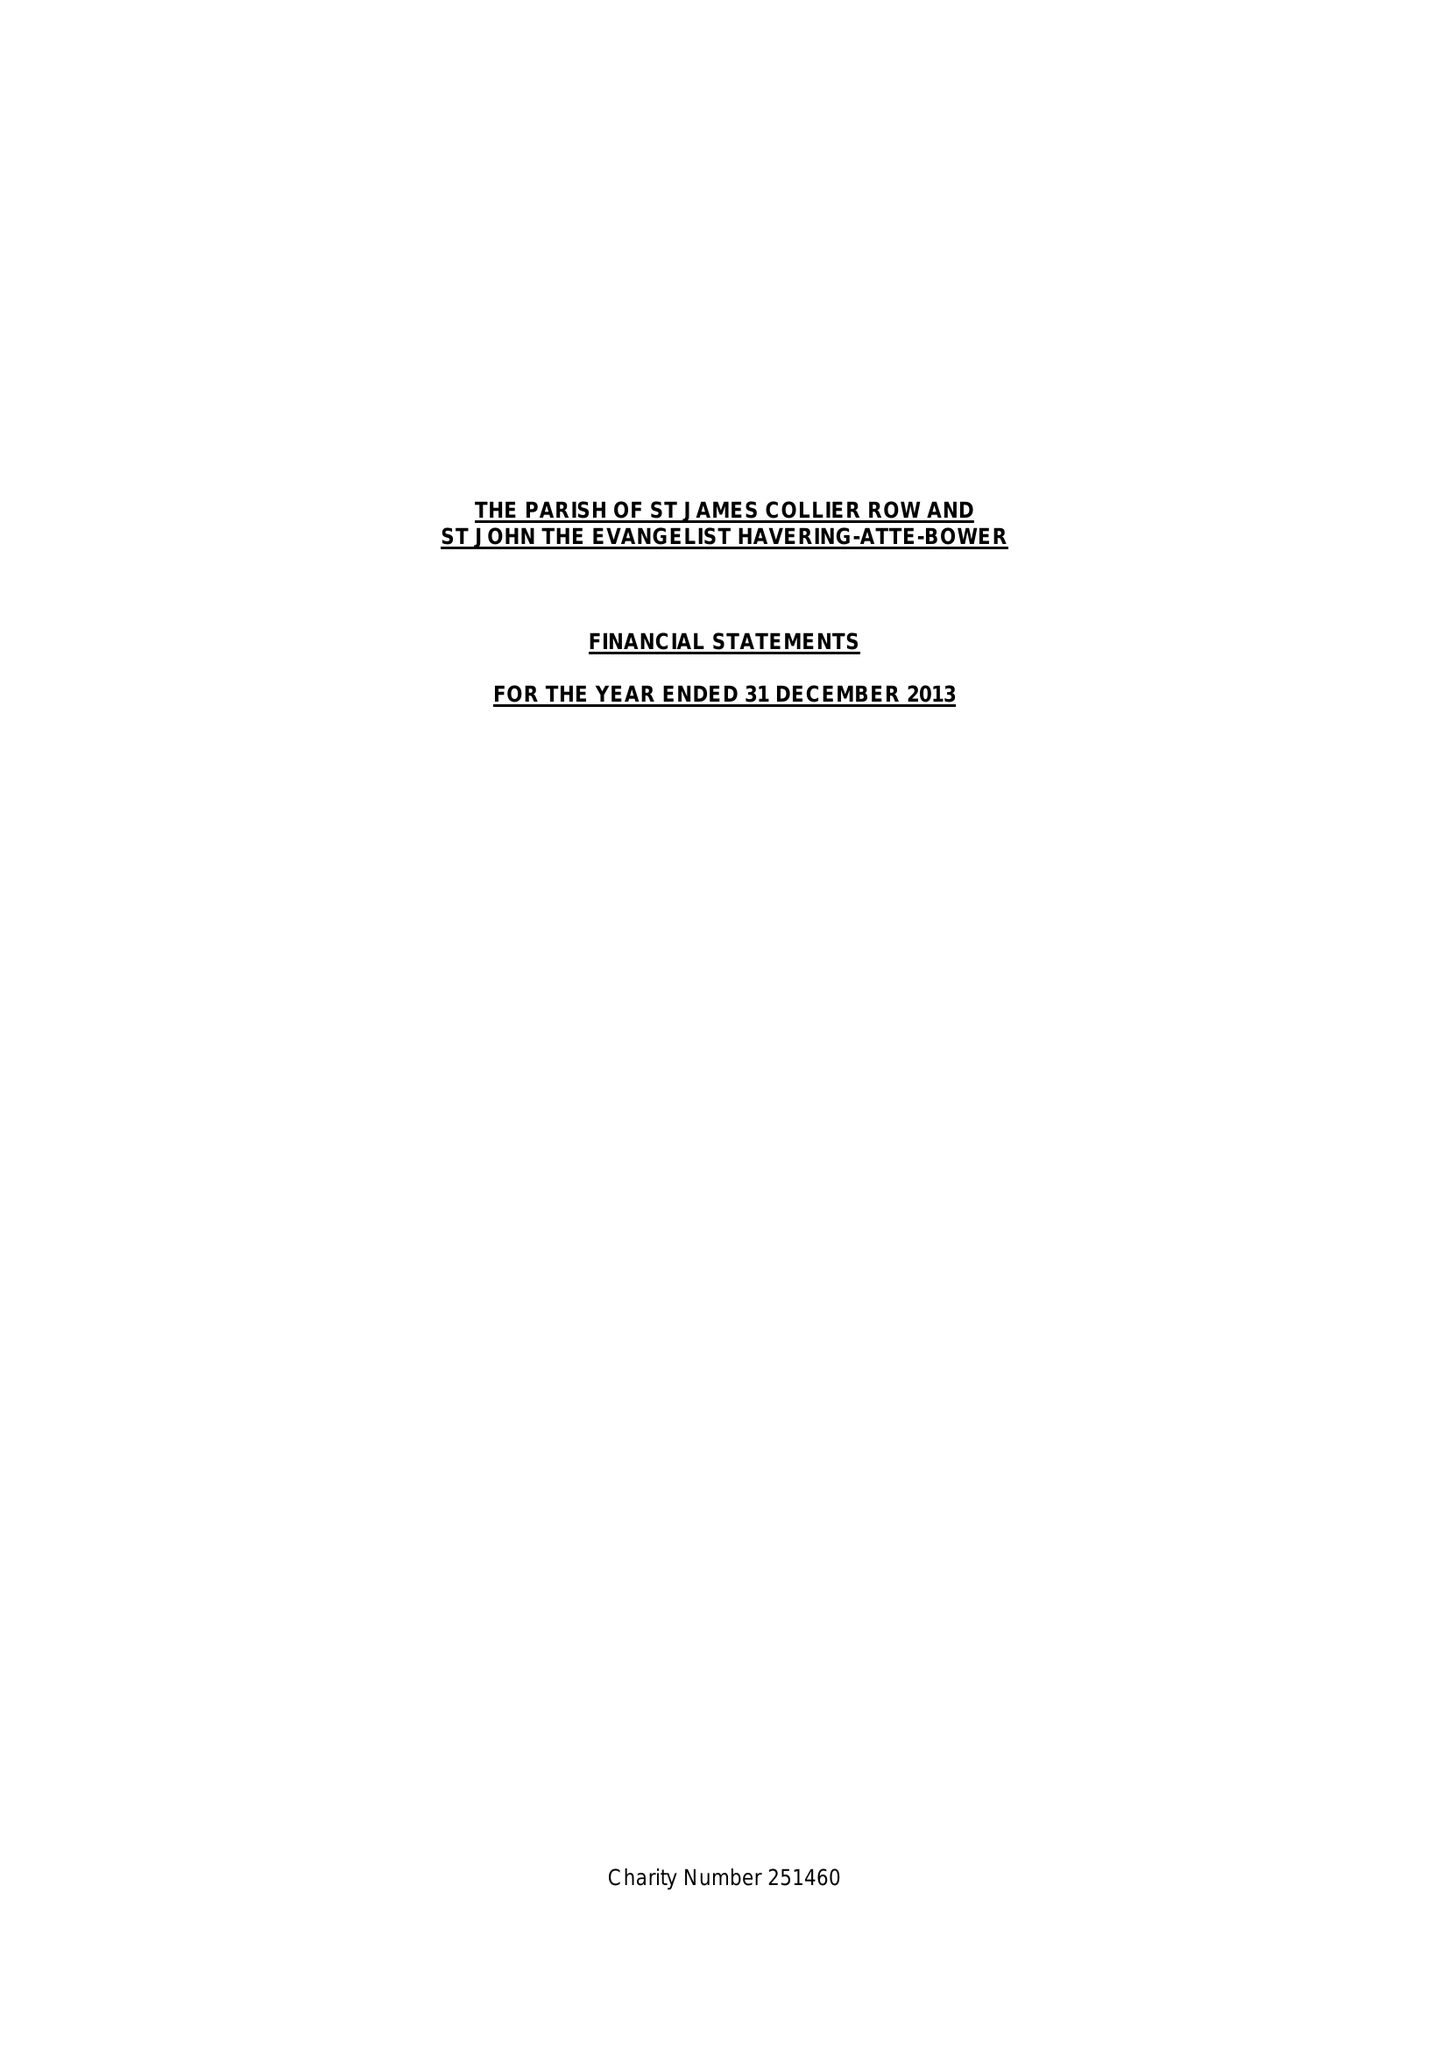What is the value for the spending_annually_in_british_pounds?
Answer the question using a single word or phrase. 164118.00 